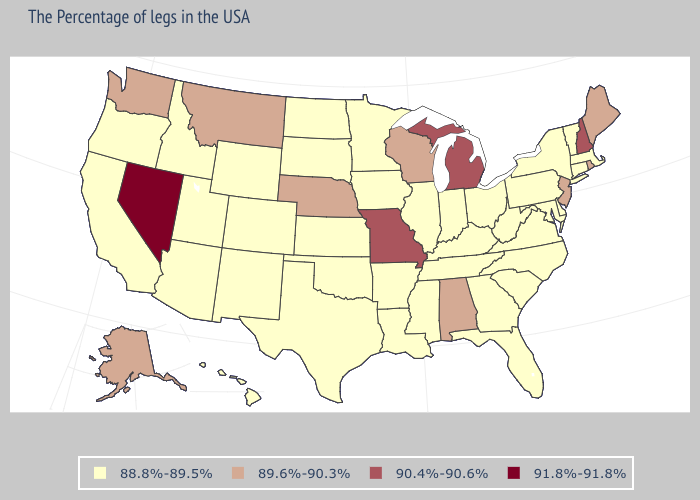Does Massachusetts have a higher value than Minnesota?
Quick response, please. No. What is the highest value in states that border Vermont?
Write a very short answer. 90.4%-90.6%. What is the value of Arkansas?
Keep it brief. 88.8%-89.5%. Does the first symbol in the legend represent the smallest category?
Be succinct. Yes. Name the states that have a value in the range 88.8%-89.5%?
Give a very brief answer. Massachusetts, Vermont, Connecticut, New York, Delaware, Maryland, Pennsylvania, Virginia, North Carolina, South Carolina, West Virginia, Ohio, Florida, Georgia, Kentucky, Indiana, Tennessee, Illinois, Mississippi, Louisiana, Arkansas, Minnesota, Iowa, Kansas, Oklahoma, Texas, South Dakota, North Dakota, Wyoming, Colorado, New Mexico, Utah, Arizona, Idaho, California, Oregon, Hawaii. What is the value of Pennsylvania?
Give a very brief answer. 88.8%-89.5%. What is the lowest value in the Northeast?
Quick response, please. 88.8%-89.5%. Among the states that border Idaho , which have the lowest value?
Write a very short answer. Wyoming, Utah, Oregon. Name the states that have a value in the range 88.8%-89.5%?
Concise answer only. Massachusetts, Vermont, Connecticut, New York, Delaware, Maryland, Pennsylvania, Virginia, North Carolina, South Carolina, West Virginia, Ohio, Florida, Georgia, Kentucky, Indiana, Tennessee, Illinois, Mississippi, Louisiana, Arkansas, Minnesota, Iowa, Kansas, Oklahoma, Texas, South Dakota, North Dakota, Wyoming, Colorado, New Mexico, Utah, Arizona, Idaho, California, Oregon, Hawaii. Which states hav the highest value in the Northeast?
Short answer required. New Hampshire. Name the states that have a value in the range 91.8%-91.8%?
Write a very short answer. Nevada. What is the value of Kentucky?
Concise answer only. 88.8%-89.5%. What is the lowest value in the USA?
Keep it brief. 88.8%-89.5%. Among the states that border North Dakota , which have the lowest value?
Concise answer only. Minnesota, South Dakota. Which states have the lowest value in the USA?
Give a very brief answer. Massachusetts, Vermont, Connecticut, New York, Delaware, Maryland, Pennsylvania, Virginia, North Carolina, South Carolina, West Virginia, Ohio, Florida, Georgia, Kentucky, Indiana, Tennessee, Illinois, Mississippi, Louisiana, Arkansas, Minnesota, Iowa, Kansas, Oklahoma, Texas, South Dakota, North Dakota, Wyoming, Colorado, New Mexico, Utah, Arizona, Idaho, California, Oregon, Hawaii. 